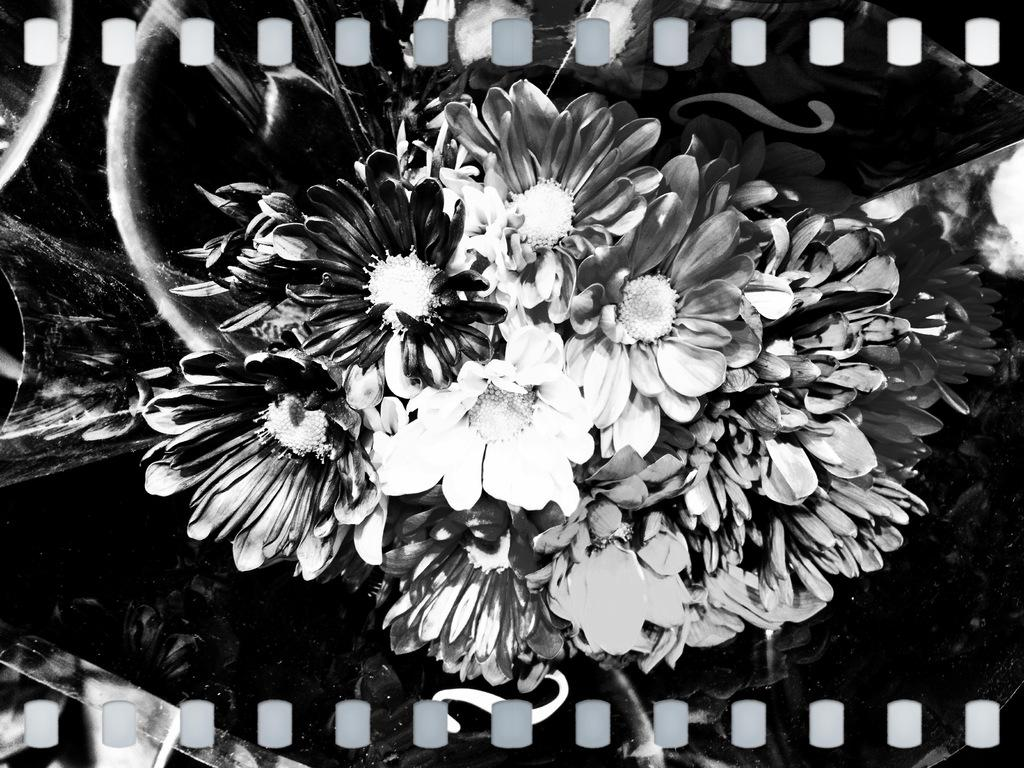What type of living organisms can be seen in the image? Flowers can be seen in the image. What type of pizzas can be seen in the image? There are no pizzas present in the image; it features flowers. What substance is being used to turn the flowers in the image? There is no substance or action of turning the flowers in the image; they are stationary. 